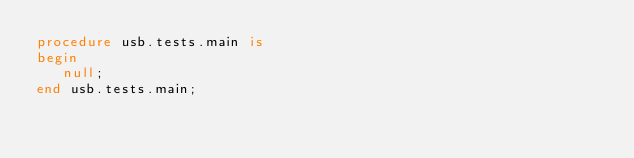<code> <loc_0><loc_0><loc_500><loc_500><_Ada_>procedure usb.tests.main is
begin
   null;
end usb.tests.main;
</code> 